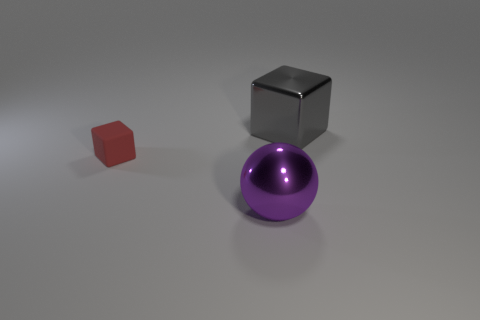Add 3 purple matte objects. How many objects exist? 6 Subtract all balls. How many objects are left? 2 Add 2 small yellow rubber things. How many small yellow rubber things exist? 2 Subtract 0 brown balls. How many objects are left? 3 Subtract all metal spheres. Subtract all small red matte things. How many objects are left? 1 Add 2 purple metallic spheres. How many purple metallic spheres are left? 3 